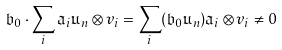Convert formula to latex. <formula><loc_0><loc_0><loc_500><loc_500>\mathfrak { b } _ { 0 } \cdot \sum _ { i } \mathfrak { a } _ { i } \mathfrak { u } _ { n } \otimes v _ { i } = \sum _ { i } ( \mathfrak { b } _ { 0 } \mathfrak { u } _ { n } ) \mathfrak { a } _ { i } \otimes v _ { i } \neq 0</formula> 